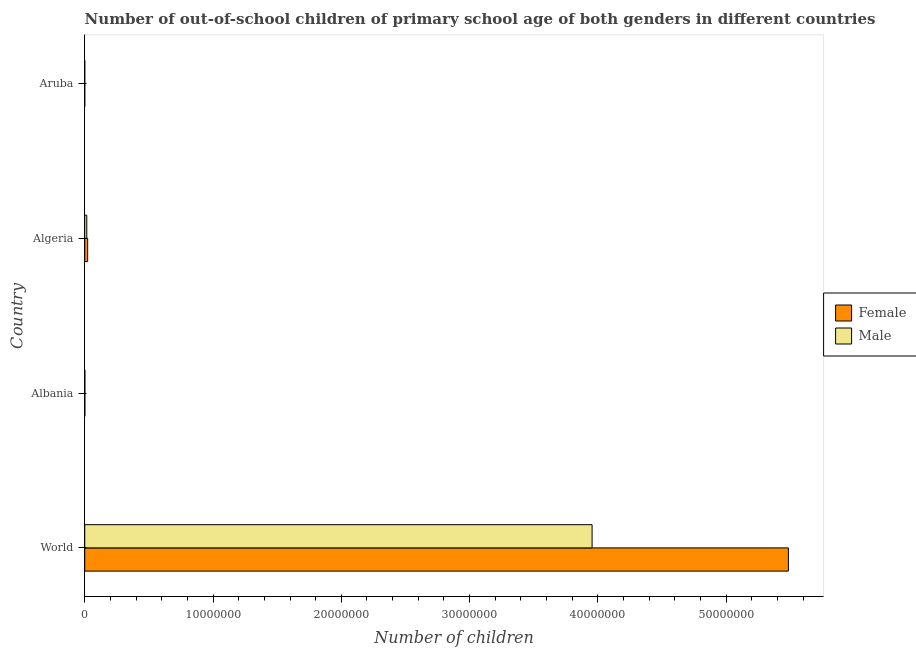How many different coloured bars are there?
Your answer should be compact. 2. How many groups of bars are there?
Your answer should be very brief. 4. Are the number of bars per tick equal to the number of legend labels?
Offer a very short reply. Yes. Are the number of bars on each tick of the Y-axis equal?
Offer a very short reply. Yes. What is the label of the 3rd group of bars from the top?
Provide a succinct answer. Albania. In how many cases, is the number of bars for a given country not equal to the number of legend labels?
Your answer should be compact. 0. What is the number of female out-of-school students in World?
Ensure brevity in your answer.  5.49e+07. Across all countries, what is the maximum number of male out-of-school students?
Keep it short and to the point. 3.95e+07. Across all countries, what is the minimum number of male out-of-school students?
Keep it short and to the point. 158. In which country was the number of male out-of-school students minimum?
Offer a terse response. Aruba. What is the total number of female out-of-school students in the graph?
Your response must be concise. 5.51e+07. What is the difference between the number of female out-of-school students in Algeria and that in World?
Your answer should be very brief. -5.46e+07. What is the difference between the number of male out-of-school students in World and the number of female out-of-school students in Aruba?
Offer a terse response. 3.95e+07. What is the average number of male out-of-school students per country?
Give a very brief answer. 9.93e+06. What is the difference between the number of female out-of-school students and number of male out-of-school students in Albania?
Offer a very short reply. 657. What is the ratio of the number of female out-of-school students in Albania to that in Algeria?
Provide a short and direct response. 0.04. Is the number of female out-of-school students in Algeria less than that in Aruba?
Your answer should be compact. No. Is the difference between the number of male out-of-school students in Aruba and World greater than the difference between the number of female out-of-school students in Aruba and World?
Make the answer very short. Yes. What is the difference between the highest and the second highest number of male out-of-school students?
Your response must be concise. 3.94e+07. What is the difference between the highest and the lowest number of female out-of-school students?
Ensure brevity in your answer.  5.49e+07. Is the sum of the number of male out-of-school students in Albania and Aruba greater than the maximum number of female out-of-school students across all countries?
Keep it short and to the point. No. What does the 2nd bar from the bottom in Algeria represents?
Your answer should be very brief. Male. Are all the bars in the graph horizontal?
Offer a terse response. Yes. Does the graph contain grids?
Keep it short and to the point. No. Where does the legend appear in the graph?
Your answer should be very brief. Center right. How are the legend labels stacked?
Your answer should be very brief. Vertical. What is the title of the graph?
Keep it short and to the point. Number of out-of-school children of primary school age of both genders in different countries. What is the label or title of the X-axis?
Keep it short and to the point. Number of children. What is the Number of children of Female in World?
Your response must be concise. 5.49e+07. What is the Number of children in Male in World?
Keep it short and to the point. 3.95e+07. What is the Number of children of Female in Albania?
Your response must be concise. 9024. What is the Number of children of Male in Albania?
Provide a succinct answer. 8367. What is the Number of children in Female in Algeria?
Provide a succinct answer. 2.28e+05. What is the Number of children in Male in Algeria?
Ensure brevity in your answer.  1.60e+05. What is the Number of children in Female in Aruba?
Offer a very short reply. 134. What is the Number of children of Male in Aruba?
Make the answer very short. 158. Across all countries, what is the maximum Number of children of Female?
Provide a succinct answer. 5.49e+07. Across all countries, what is the maximum Number of children of Male?
Offer a very short reply. 3.95e+07. Across all countries, what is the minimum Number of children of Female?
Your answer should be very brief. 134. Across all countries, what is the minimum Number of children in Male?
Provide a succinct answer. 158. What is the total Number of children in Female in the graph?
Keep it short and to the point. 5.51e+07. What is the total Number of children of Male in the graph?
Give a very brief answer. 3.97e+07. What is the difference between the Number of children in Female in World and that in Albania?
Ensure brevity in your answer.  5.48e+07. What is the difference between the Number of children of Male in World and that in Albania?
Your response must be concise. 3.95e+07. What is the difference between the Number of children in Female in World and that in Algeria?
Ensure brevity in your answer.  5.46e+07. What is the difference between the Number of children in Male in World and that in Algeria?
Make the answer very short. 3.94e+07. What is the difference between the Number of children in Female in World and that in Aruba?
Your answer should be very brief. 5.49e+07. What is the difference between the Number of children of Male in World and that in Aruba?
Your answer should be very brief. 3.95e+07. What is the difference between the Number of children of Female in Albania and that in Algeria?
Offer a terse response. -2.19e+05. What is the difference between the Number of children of Male in Albania and that in Algeria?
Make the answer very short. -1.51e+05. What is the difference between the Number of children in Female in Albania and that in Aruba?
Provide a succinct answer. 8890. What is the difference between the Number of children in Male in Albania and that in Aruba?
Your answer should be compact. 8209. What is the difference between the Number of children in Female in Algeria and that in Aruba?
Provide a short and direct response. 2.28e+05. What is the difference between the Number of children in Male in Algeria and that in Aruba?
Offer a terse response. 1.59e+05. What is the difference between the Number of children of Female in World and the Number of children of Male in Albania?
Keep it short and to the point. 5.48e+07. What is the difference between the Number of children in Female in World and the Number of children in Male in Algeria?
Your answer should be compact. 5.47e+07. What is the difference between the Number of children of Female in World and the Number of children of Male in Aruba?
Give a very brief answer. 5.49e+07. What is the difference between the Number of children in Female in Albania and the Number of children in Male in Algeria?
Offer a terse response. -1.51e+05. What is the difference between the Number of children in Female in Albania and the Number of children in Male in Aruba?
Give a very brief answer. 8866. What is the difference between the Number of children of Female in Algeria and the Number of children of Male in Aruba?
Make the answer very short. 2.28e+05. What is the average Number of children in Female per country?
Give a very brief answer. 1.38e+07. What is the average Number of children of Male per country?
Give a very brief answer. 9.93e+06. What is the difference between the Number of children in Female and Number of children in Male in World?
Keep it short and to the point. 1.53e+07. What is the difference between the Number of children of Female and Number of children of Male in Albania?
Keep it short and to the point. 657. What is the difference between the Number of children of Female and Number of children of Male in Algeria?
Keep it short and to the point. 6.87e+04. What is the ratio of the Number of children in Female in World to that in Albania?
Ensure brevity in your answer.  6078.28. What is the ratio of the Number of children of Male in World to that in Albania?
Your answer should be very brief. 4726.69. What is the ratio of the Number of children of Female in World to that in Algeria?
Ensure brevity in your answer.  240.34. What is the ratio of the Number of children in Male in World to that in Algeria?
Give a very brief answer. 247.86. What is the ratio of the Number of children in Female in World to that in Aruba?
Provide a succinct answer. 4.09e+05. What is the ratio of the Number of children in Male in World to that in Aruba?
Your answer should be compact. 2.50e+05. What is the ratio of the Number of children in Female in Albania to that in Algeria?
Provide a succinct answer. 0.04. What is the ratio of the Number of children in Male in Albania to that in Algeria?
Make the answer very short. 0.05. What is the ratio of the Number of children of Female in Albania to that in Aruba?
Your response must be concise. 67.34. What is the ratio of the Number of children of Male in Albania to that in Aruba?
Give a very brief answer. 52.96. What is the ratio of the Number of children in Female in Algeria to that in Aruba?
Offer a terse response. 1703.12. What is the ratio of the Number of children of Male in Algeria to that in Aruba?
Your answer should be very brief. 1009.86. What is the difference between the highest and the second highest Number of children in Female?
Keep it short and to the point. 5.46e+07. What is the difference between the highest and the second highest Number of children in Male?
Offer a very short reply. 3.94e+07. What is the difference between the highest and the lowest Number of children of Female?
Provide a short and direct response. 5.49e+07. What is the difference between the highest and the lowest Number of children in Male?
Your answer should be very brief. 3.95e+07. 